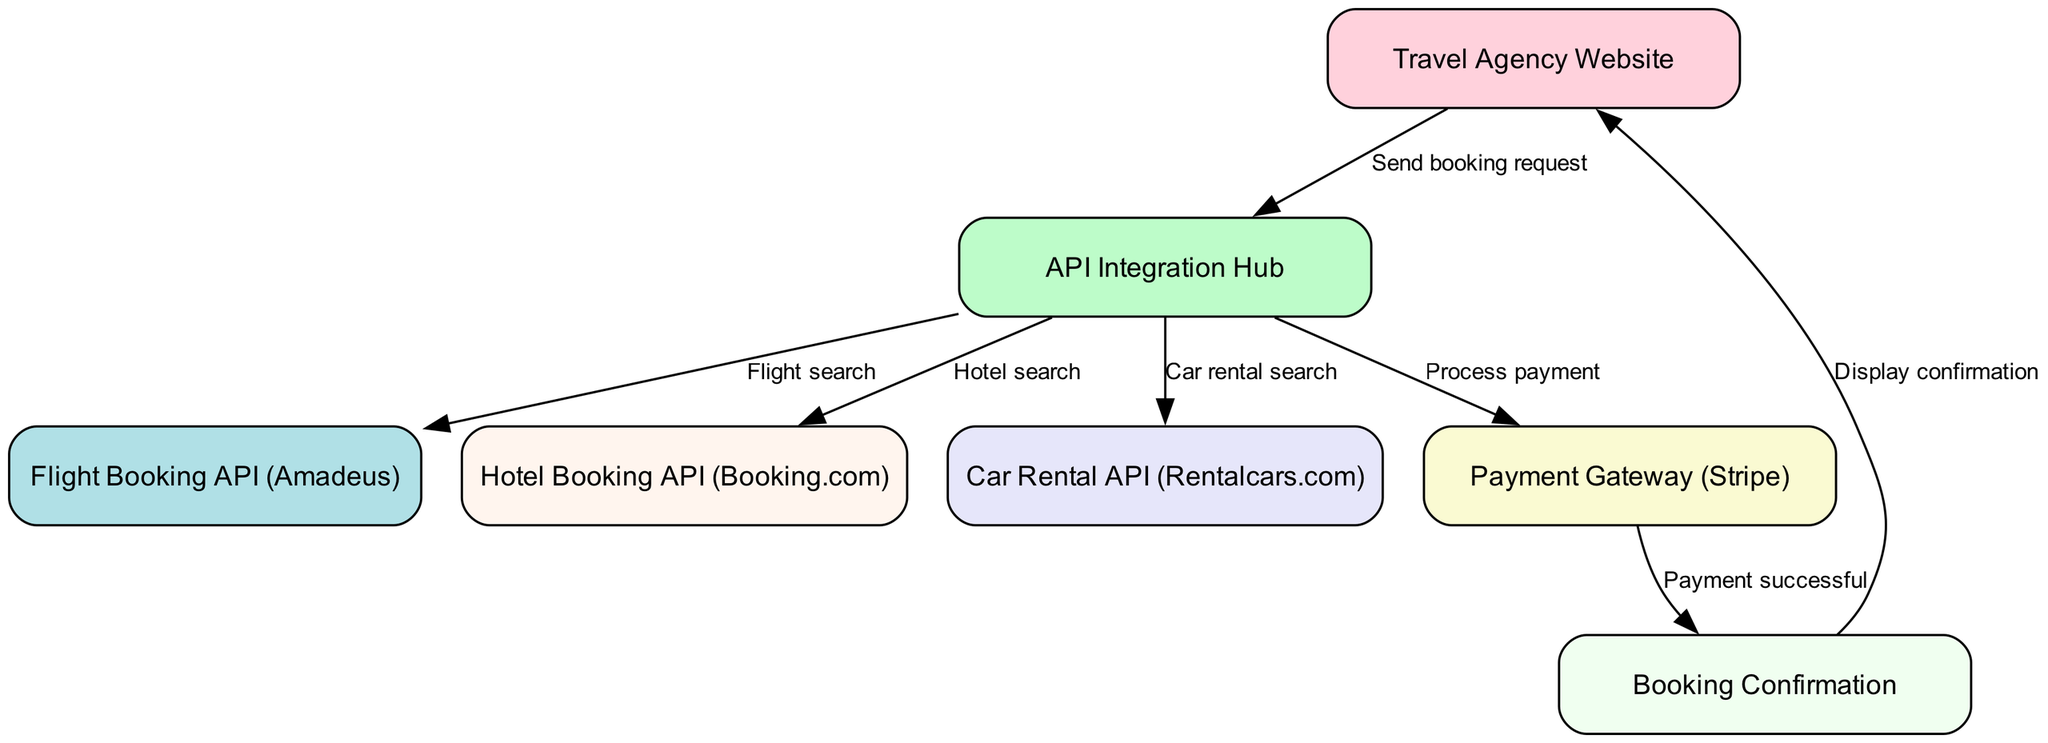What is the starting node of the flow chart? The starting node is "Travel Agency Website," which initiates the booking request process.
Answer: Travel Agency Website How many total nodes are present in the diagram? The diagram consists of seven nodes that represent various components involved in the booking and payment processes.
Answer: 7 What action is taken after sending the booking request? After sending the booking request, the next action is to send it to the "API Integration Hub" for further processing.
Answer: API Integration Hub What type of API is used for flight booking? The diagram specifies that the "Flight Booking API" for flight searches is Amadeus.
Answer: Amadeus What is the final step of the flow after confirming payment? The final step after confirming payment is displaying the booking confirmation to the user on the travel agency website.
Answer: Display confirmation How many different services are searched through the API Integration Hub? The API Integration Hub searches for three different services: flight, hotel, and car rental.
Answer: 3 Which node follows the Payment Gateway in the process? The node that follows the Payment Gateway, indicating successful payment, is the "Booking Confirmation."
Answer: Booking Confirmation What happens if the payment is successful? If the payment is successful, a confirmation is generated, which is then displayed to the user.
Answer: Display confirmation What type of service does "Hotel Booking API" refer to? The "Hotel Booking API" refers to services provided by Booking.com, specifically for hotel searches.
Answer: Booking.com 